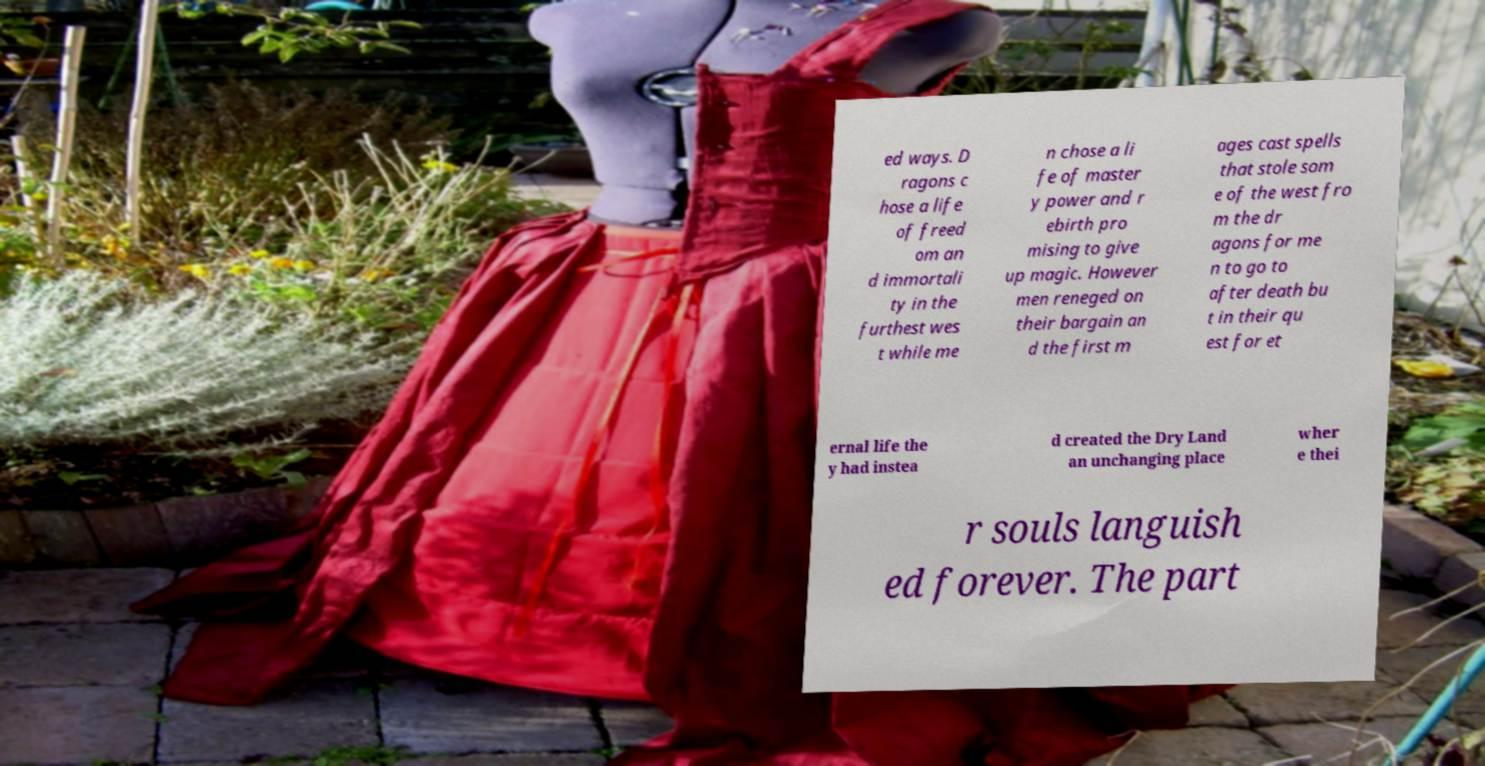Please identify and transcribe the text found in this image. ed ways. D ragons c hose a life of freed om an d immortali ty in the furthest wes t while me n chose a li fe of master y power and r ebirth pro mising to give up magic. However men reneged on their bargain an d the first m ages cast spells that stole som e of the west fro m the dr agons for me n to go to after death bu t in their qu est for et ernal life the y had instea d created the Dry Land an unchanging place wher e thei r souls languish ed forever. The part 